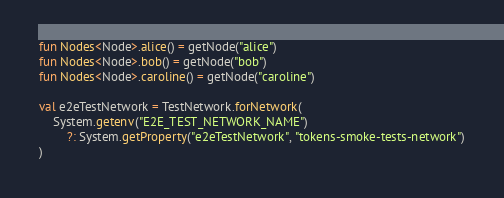Convert code to text. <code><loc_0><loc_0><loc_500><loc_500><_Kotlin_>
fun Nodes<Node>.alice() = getNode("alice")
fun Nodes<Node>.bob() = getNode("bob")
fun Nodes<Node>.caroline() = getNode("caroline")

val e2eTestNetwork = TestNetwork.forNetwork(
    System.getenv("E2E_TEST_NETWORK_NAME")
        ?: System.getProperty("e2eTestNetwork", "tokens-smoke-tests-network")
)
</code> 